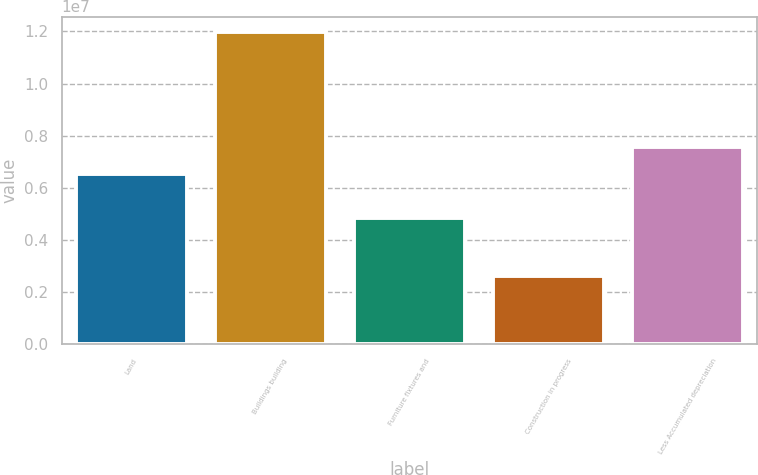Convert chart. <chart><loc_0><loc_0><loc_500><loc_500><bar_chart><fcel>Land<fcel>Buildings building<fcel>Furniture fixtures and<fcel>Construction in progress<fcel>Less Accumulated depreciation<nl><fcel>6.53099e+06<fcel>1.197e+07<fcel>4.86365e+06<fcel>2.6286e+06<fcel>7.5682e+06<nl></chart> 